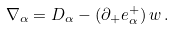<formula> <loc_0><loc_0><loc_500><loc_500>\nabla _ { \alpha } = D _ { \alpha } - ( \partial _ { + } e ^ { + } _ { \alpha } ) \, w \, .</formula> 